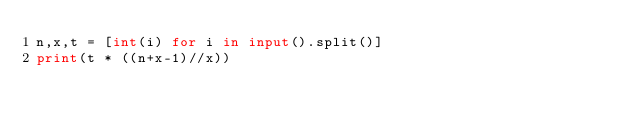<code> <loc_0><loc_0><loc_500><loc_500><_Python_>n,x,t = [int(i) for i in input().split()]
print(t * ((n+x-1)//x))</code> 